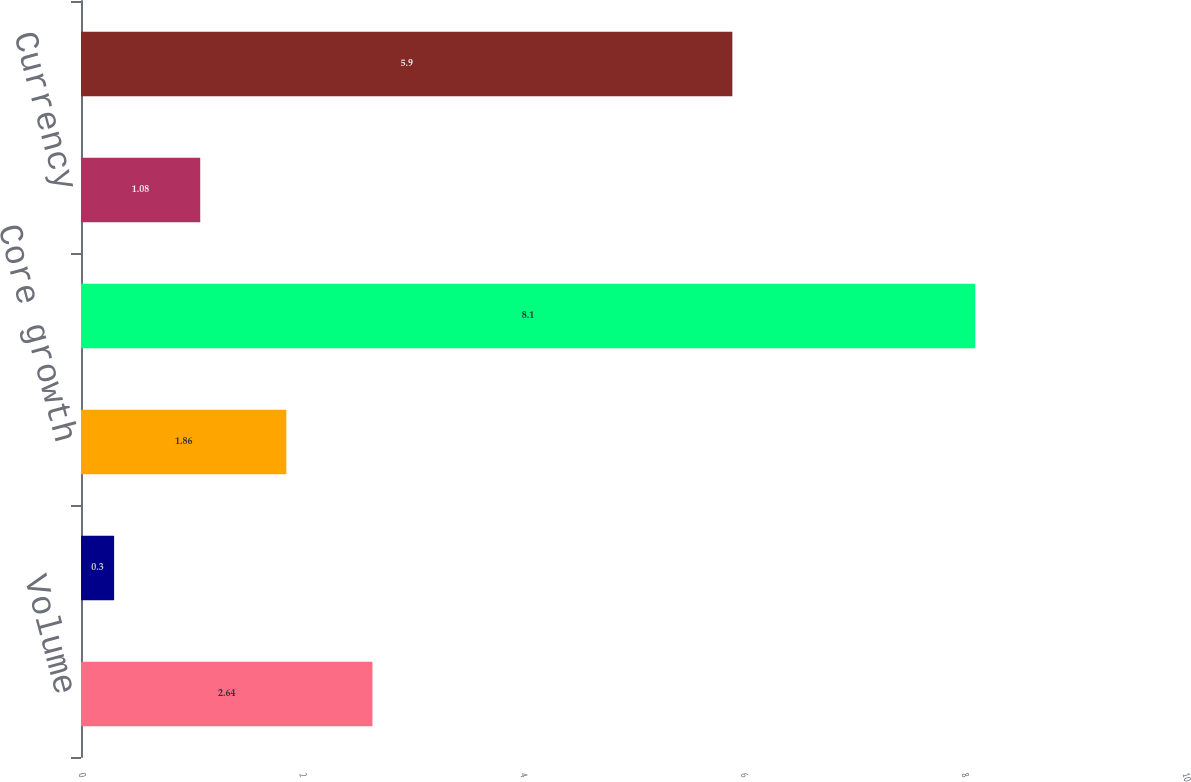Convert chart to OTSL. <chart><loc_0><loc_0><loc_500><loc_500><bar_chart><fcel>Volume<fcel>Price<fcel>Core growth<fcel>Acquisition<fcel>Currency<fcel>Total<nl><fcel>2.64<fcel>0.3<fcel>1.86<fcel>8.1<fcel>1.08<fcel>5.9<nl></chart> 